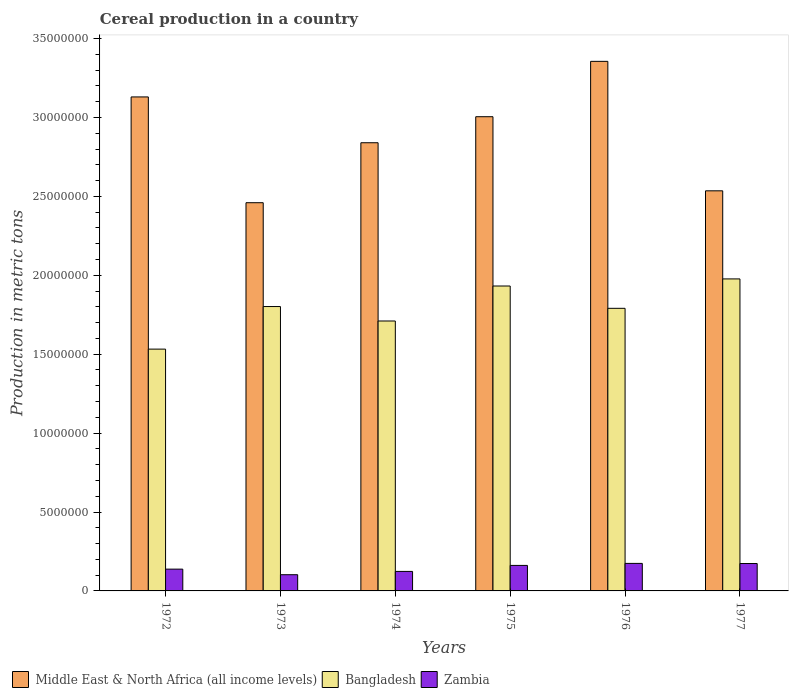How many groups of bars are there?
Give a very brief answer. 6. Are the number of bars on each tick of the X-axis equal?
Ensure brevity in your answer.  Yes. How many bars are there on the 4th tick from the left?
Offer a terse response. 3. How many bars are there on the 6th tick from the right?
Your answer should be compact. 3. What is the label of the 5th group of bars from the left?
Ensure brevity in your answer.  1976. In how many cases, is the number of bars for a given year not equal to the number of legend labels?
Provide a succinct answer. 0. What is the total cereal production in Bangladesh in 1974?
Your response must be concise. 1.71e+07. Across all years, what is the maximum total cereal production in Bangladesh?
Offer a very short reply. 1.98e+07. Across all years, what is the minimum total cereal production in Middle East & North Africa (all income levels)?
Your answer should be compact. 2.46e+07. In which year was the total cereal production in Bangladesh maximum?
Make the answer very short. 1977. What is the total total cereal production in Bangladesh in the graph?
Offer a very short reply. 1.07e+08. What is the difference between the total cereal production in Middle East & North Africa (all income levels) in 1973 and that in 1977?
Offer a terse response. -7.53e+05. What is the difference between the total cereal production in Bangladesh in 1977 and the total cereal production in Middle East & North Africa (all income levels) in 1976?
Offer a terse response. -1.38e+07. What is the average total cereal production in Zambia per year?
Provide a short and direct response. 1.46e+06. In the year 1972, what is the difference between the total cereal production in Middle East & North Africa (all income levels) and total cereal production in Bangladesh?
Provide a short and direct response. 1.60e+07. In how many years, is the total cereal production in Middle East & North Africa (all income levels) greater than 21000000 metric tons?
Provide a short and direct response. 6. What is the ratio of the total cereal production in Zambia in 1974 to that in 1977?
Offer a very short reply. 0.71. Is the total cereal production in Zambia in 1974 less than that in 1977?
Your response must be concise. Yes. What is the difference between the highest and the second highest total cereal production in Zambia?
Provide a succinct answer. 8285. What is the difference between the highest and the lowest total cereal production in Zambia?
Offer a terse response. 7.17e+05. In how many years, is the total cereal production in Zambia greater than the average total cereal production in Zambia taken over all years?
Your answer should be very brief. 3. What does the 3rd bar from the left in 1974 represents?
Provide a short and direct response. Zambia. What does the 2nd bar from the right in 1976 represents?
Ensure brevity in your answer.  Bangladesh. How many bars are there?
Give a very brief answer. 18. Are all the bars in the graph horizontal?
Your answer should be compact. No. How many years are there in the graph?
Provide a succinct answer. 6. Are the values on the major ticks of Y-axis written in scientific E-notation?
Provide a short and direct response. No. What is the title of the graph?
Your answer should be very brief. Cereal production in a country. What is the label or title of the Y-axis?
Your answer should be very brief. Production in metric tons. What is the Production in metric tons in Middle East & North Africa (all income levels) in 1972?
Offer a terse response. 3.13e+07. What is the Production in metric tons of Bangladesh in 1972?
Ensure brevity in your answer.  1.53e+07. What is the Production in metric tons in Zambia in 1972?
Ensure brevity in your answer.  1.38e+06. What is the Production in metric tons of Middle East & North Africa (all income levels) in 1973?
Your answer should be compact. 2.46e+07. What is the Production in metric tons in Bangladesh in 1973?
Make the answer very short. 1.80e+07. What is the Production in metric tons of Zambia in 1973?
Offer a very short reply. 1.03e+06. What is the Production in metric tons of Middle East & North Africa (all income levels) in 1974?
Make the answer very short. 2.84e+07. What is the Production in metric tons in Bangladesh in 1974?
Make the answer very short. 1.71e+07. What is the Production in metric tons in Zambia in 1974?
Your answer should be compact. 1.24e+06. What is the Production in metric tons of Middle East & North Africa (all income levels) in 1975?
Provide a succinct answer. 3.01e+07. What is the Production in metric tons in Bangladesh in 1975?
Make the answer very short. 1.93e+07. What is the Production in metric tons of Zambia in 1975?
Ensure brevity in your answer.  1.62e+06. What is the Production in metric tons of Middle East & North Africa (all income levels) in 1976?
Give a very brief answer. 3.36e+07. What is the Production in metric tons in Bangladesh in 1976?
Offer a terse response. 1.79e+07. What is the Production in metric tons in Zambia in 1976?
Offer a terse response. 1.74e+06. What is the Production in metric tons in Middle East & North Africa (all income levels) in 1977?
Your response must be concise. 2.54e+07. What is the Production in metric tons in Bangladesh in 1977?
Give a very brief answer. 1.98e+07. What is the Production in metric tons in Zambia in 1977?
Give a very brief answer. 1.74e+06. Across all years, what is the maximum Production in metric tons in Middle East & North Africa (all income levels)?
Your answer should be compact. 3.36e+07. Across all years, what is the maximum Production in metric tons of Bangladesh?
Your response must be concise. 1.98e+07. Across all years, what is the maximum Production in metric tons of Zambia?
Give a very brief answer. 1.74e+06. Across all years, what is the minimum Production in metric tons of Middle East & North Africa (all income levels)?
Offer a very short reply. 2.46e+07. Across all years, what is the minimum Production in metric tons of Bangladesh?
Your answer should be very brief. 1.53e+07. Across all years, what is the minimum Production in metric tons of Zambia?
Make the answer very short. 1.03e+06. What is the total Production in metric tons in Middle East & North Africa (all income levels) in the graph?
Your answer should be compact. 1.73e+08. What is the total Production in metric tons of Bangladesh in the graph?
Provide a short and direct response. 1.07e+08. What is the total Production in metric tons of Zambia in the graph?
Your answer should be very brief. 8.74e+06. What is the difference between the Production in metric tons in Middle East & North Africa (all income levels) in 1972 and that in 1973?
Offer a terse response. 6.70e+06. What is the difference between the Production in metric tons in Bangladesh in 1972 and that in 1973?
Ensure brevity in your answer.  -2.70e+06. What is the difference between the Production in metric tons of Zambia in 1972 and that in 1973?
Provide a short and direct response. 3.53e+05. What is the difference between the Production in metric tons in Middle East & North Africa (all income levels) in 1972 and that in 1974?
Ensure brevity in your answer.  2.90e+06. What is the difference between the Production in metric tons in Bangladesh in 1972 and that in 1974?
Offer a terse response. -1.78e+06. What is the difference between the Production in metric tons in Zambia in 1972 and that in 1974?
Offer a terse response. 1.44e+05. What is the difference between the Production in metric tons of Middle East & North Africa (all income levels) in 1972 and that in 1975?
Make the answer very short. 1.25e+06. What is the difference between the Production in metric tons of Bangladesh in 1972 and that in 1975?
Your answer should be compact. -4.00e+06. What is the difference between the Production in metric tons in Zambia in 1972 and that in 1975?
Your response must be concise. -2.36e+05. What is the difference between the Production in metric tons in Middle East & North Africa (all income levels) in 1972 and that in 1976?
Provide a succinct answer. -2.25e+06. What is the difference between the Production in metric tons in Bangladesh in 1972 and that in 1976?
Make the answer very short. -2.58e+06. What is the difference between the Production in metric tons in Zambia in 1972 and that in 1976?
Your answer should be very brief. -3.64e+05. What is the difference between the Production in metric tons in Middle East & North Africa (all income levels) in 1972 and that in 1977?
Give a very brief answer. 5.95e+06. What is the difference between the Production in metric tons of Bangladesh in 1972 and that in 1977?
Your answer should be very brief. -4.45e+06. What is the difference between the Production in metric tons of Zambia in 1972 and that in 1977?
Your answer should be compact. -3.56e+05. What is the difference between the Production in metric tons of Middle East & North Africa (all income levels) in 1973 and that in 1974?
Make the answer very short. -3.80e+06. What is the difference between the Production in metric tons in Bangladesh in 1973 and that in 1974?
Your answer should be very brief. 9.16e+05. What is the difference between the Production in metric tons in Zambia in 1973 and that in 1974?
Offer a very short reply. -2.09e+05. What is the difference between the Production in metric tons in Middle East & North Africa (all income levels) in 1973 and that in 1975?
Your response must be concise. -5.45e+06. What is the difference between the Production in metric tons of Bangladesh in 1973 and that in 1975?
Your answer should be compact. -1.30e+06. What is the difference between the Production in metric tons in Zambia in 1973 and that in 1975?
Offer a very short reply. -5.89e+05. What is the difference between the Production in metric tons in Middle East & North Africa (all income levels) in 1973 and that in 1976?
Your response must be concise. -8.96e+06. What is the difference between the Production in metric tons in Bangladesh in 1973 and that in 1976?
Your response must be concise. 1.13e+05. What is the difference between the Production in metric tons of Zambia in 1973 and that in 1976?
Your response must be concise. -7.17e+05. What is the difference between the Production in metric tons of Middle East & North Africa (all income levels) in 1973 and that in 1977?
Make the answer very short. -7.53e+05. What is the difference between the Production in metric tons of Bangladesh in 1973 and that in 1977?
Provide a succinct answer. -1.75e+06. What is the difference between the Production in metric tons in Zambia in 1973 and that in 1977?
Provide a short and direct response. -7.09e+05. What is the difference between the Production in metric tons of Middle East & North Africa (all income levels) in 1974 and that in 1975?
Your response must be concise. -1.65e+06. What is the difference between the Production in metric tons of Bangladesh in 1974 and that in 1975?
Provide a succinct answer. -2.22e+06. What is the difference between the Production in metric tons in Zambia in 1974 and that in 1975?
Provide a succinct answer. -3.80e+05. What is the difference between the Production in metric tons of Middle East & North Africa (all income levels) in 1974 and that in 1976?
Offer a terse response. -5.16e+06. What is the difference between the Production in metric tons in Bangladesh in 1974 and that in 1976?
Make the answer very short. -8.03e+05. What is the difference between the Production in metric tons of Zambia in 1974 and that in 1976?
Offer a terse response. -5.08e+05. What is the difference between the Production in metric tons in Middle East & North Africa (all income levels) in 1974 and that in 1977?
Ensure brevity in your answer.  3.05e+06. What is the difference between the Production in metric tons of Bangladesh in 1974 and that in 1977?
Keep it short and to the point. -2.67e+06. What is the difference between the Production in metric tons in Zambia in 1974 and that in 1977?
Offer a terse response. -5.00e+05. What is the difference between the Production in metric tons in Middle East & North Africa (all income levels) in 1975 and that in 1976?
Ensure brevity in your answer.  -3.51e+06. What is the difference between the Production in metric tons in Bangladesh in 1975 and that in 1976?
Provide a succinct answer. 1.41e+06. What is the difference between the Production in metric tons in Zambia in 1975 and that in 1976?
Offer a very short reply. -1.28e+05. What is the difference between the Production in metric tons of Middle East & North Africa (all income levels) in 1975 and that in 1977?
Your answer should be very brief. 4.70e+06. What is the difference between the Production in metric tons of Bangladesh in 1975 and that in 1977?
Give a very brief answer. -4.50e+05. What is the difference between the Production in metric tons of Zambia in 1975 and that in 1977?
Ensure brevity in your answer.  -1.20e+05. What is the difference between the Production in metric tons in Middle East & North Africa (all income levels) in 1976 and that in 1977?
Provide a short and direct response. 8.20e+06. What is the difference between the Production in metric tons of Bangladesh in 1976 and that in 1977?
Your answer should be compact. -1.86e+06. What is the difference between the Production in metric tons of Zambia in 1976 and that in 1977?
Provide a succinct answer. 8285. What is the difference between the Production in metric tons in Middle East & North Africa (all income levels) in 1972 and the Production in metric tons in Bangladesh in 1973?
Offer a terse response. 1.33e+07. What is the difference between the Production in metric tons in Middle East & North Africa (all income levels) in 1972 and the Production in metric tons in Zambia in 1973?
Provide a succinct answer. 3.03e+07. What is the difference between the Production in metric tons of Bangladesh in 1972 and the Production in metric tons of Zambia in 1973?
Offer a very short reply. 1.43e+07. What is the difference between the Production in metric tons in Middle East & North Africa (all income levels) in 1972 and the Production in metric tons in Bangladesh in 1974?
Provide a short and direct response. 1.42e+07. What is the difference between the Production in metric tons in Middle East & North Africa (all income levels) in 1972 and the Production in metric tons in Zambia in 1974?
Offer a very short reply. 3.01e+07. What is the difference between the Production in metric tons in Bangladesh in 1972 and the Production in metric tons in Zambia in 1974?
Your answer should be compact. 1.41e+07. What is the difference between the Production in metric tons in Middle East & North Africa (all income levels) in 1972 and the Production in metric tons in Bangladesh in 1975?
Give a very brief answer. 1.20e+07. What is the difference between the Production in metric tons in Middle East & North Africa (all income levels) in 1972 and the Production in metric tons in Zambia in 1975?
Your answer should be compact. 2.97e+07. What is the difference between the Production in metric tons of Bangladesh in 1972 and the Production in metric tons of Zambia in 1975?
Make the answer very short. 1.37e+07. What is the difference between the Production in metric tons of Middle East & North Africa (all income levels) in 1972 and the Production in metric tons of Bangladesh in 1976?
Offer a terse response. 1.34e+07. What is the difference between the Production in metric tons in Middle East & North Africa (all income levels) in 1972 and the Production in metric tons in Zambia in 1976?
Offer a terse response. 2.96e+07. What is the difference between the Production in metric tons in Bangladesh in 1972 and the Production in metric tons in Zambia in 1976?
Your answer should be compact. 1.36e+07. What is the difference between the Production in metric tons of Middle East & North Africa (all income levels) in 1972 and the Production in metric tons of Bangladesh in 1977?
Offer a very short reply. 1.15e+07. What is the difference between the Production in metric tons in Middle East & North Africa (all income levels) in 1972 and the Production in metric tons in Zambia in 1977?
Your answer should be compact. 2.96e+07. What is the difference between the Production in metric tons of Bangladesh in 1972 and the Production in metric tons of Zambia in 1977?
Provide a short and direct response. 1.36e+07. What is the difference between the Production in metric tons in Middle East & North Africa (all income levels) in 1973 and the Production in metric tons in Bangladesh in 1974?
Give a very brief answer. 7.50e+06. What is the difference between the Production in metric tons of Middle East & North Africa (all income levels) in 1973 and the Production in metric tons of Zambia in 1974?
Your answer should be compact. 2.34e+07. What is the difference between the Production in metric tons of Bangladesh in 1973 and the Production in metric tons of Zambia in 1974?
Provide a succinct answer. 1.68e+07. What is the difference between the Production in metric tons of Middle East & North Africa (all income levels) in 1973 and the Production in metric tons of Bangladesh in 1975?
Make the answer very short. 5.28e+06. What is the difference between the Production in metric tons of Middle East & North Africa (all income levels) in 1973 and the Production in metric tons of Zambia in 1975?
Your answer should be very brief. 2.30e+07. What is the difference between the Production in metric tons in Bangladesh in 1973 and the Production in metric tons in Zambia in 1975?
Ensure brevity in your answer.  1.64e+07. What is the difference between the Production in metric tons of Middle East & North Africa (all income levels) in 1973 and the Production in metric tons of Bangladesh in 1976?
Your answer should be very brief. 6.69e+06. What is the difference between the Production in metric tons in Middle East & North Africa (all income levels) in 1973 and the Production in metric tons in Zambia in 1976?
Provide a short and direct response. 2.29e+07. What is the difference between the Production in metric tons in Bangladesh in 1973 and the Production in metric tons in Zambia in 1976?
Provide a succinct answer. 1.63e+07. What is the difference between the Production in metric tons of Middle East & North Africa (all income levels) in 1973 and the Production in metric tons of Bangladesh in 1977?
Offer a very short reply. 4.83e+06. What is the difference between the Production in metric tons in Middle East & North Africa (all income levels) in 1973 and the Production in metric tons in Zambia in 1977?
Keep it short and to the point. 2.29e+07. What is the difference between the Production in metric tons in Bangladesh in 1973 and the Production in metric tons in Zambia in 1977?
Ensure brevity in your answer.  1.63e+07. What is the difference between the Production in metric tons in Middle East & North Africa (all income levels) in 1974 and the Production in metric tons in Bangladesh in 1975?
Provide a succinct answer. 9.08e+06. What is the difference between the Production in metric tons in Middle East & North Africa (all income levels) in 1974 and the Production in metric tons in Zambia in 1975?
Your answer should be compact. 2.68e+07. What is the difference between the Production in metric tons of Bangladesh in 1974 and the Production in metric tons of Zambia in 1975?
Provide a succinct answer. 1.55e+07. What is the difference between the Production in metric tons in Middle East & North Africa (all income levels) in 1974 and the Production in metric tons in Bangladesh in 1976?
Ensure brevity in your answer.  1.05e+07. What is the difference between the Production in metric tons of Middle East & North Africa (all income levels) in 1974 and the Production in metric tons of Zambia in 1976?
Keep it short and to the point. 2.67e+07. What is the difference between the Production in metric tons of Bangladesh in 1974 and the Production in metric tons of Zambia in 1976?
Make the answer very short. 1.54e+07. What is the difference between the Production in metric tons in Middle East & North Africa (all income levels) in 1974 and the Production in metric tons in Bangladesh in 1977?
Offer a terse response. 8.63e+06. What is the difference between the Production in metric tons of Middle East & North Africa (all income levels) in 1974 and the Production in metric tons of Zambia in 1977?
Provide a succinct answer. 2.67e+07. What is the difference between the Production in metric tons in Bangladesh in 1974 and the Production in metric tons in Zambia in 1977?
Ensure brevity in your answer.  1.54e+07. What is the difference between the Production in metric tons of Middle East & North Africa (all income levels) in 1975 and the Production in metric tons of Bangladesh in 1976?
Offer a very short reply. 1.21e+07. What is the difference between the Production in metric tons of Middle East & North Africa (all income levels) in 1975 and the Production in metric tons of Zambia in 1976?
Offer a very short reply. 2.83e+07. What is the difference between the Production in metric tons in Bangladesh in 1975 and the Production in metric tons in Zambia in 1976?
Ensure brevity in your answer.  1.76e+07. What is the difference between the Production in metric tons in Middle East & North Africa (all income levels) in 1975 and the Production in metric tons in Bangladesh in 1977?
Your response must be concise. 1.03e+07. What is the difference between the Production in metric tons in Middle East & North Africa (all income levels) in 1975 and the Production in metric tons in Zambia in 1977?
Your answer should be compact. 2.83e+07. What is the difference between the Production in metric tons of Bangladesh in 1975 and the Production in metric tons of Zambia in 1977?
Your answer should be compact. 1.76e+07. What is the difference between the Production in metric tons of Middle East & North Africa (all income levels) in 1976 and the Production in metric tons of Bangladesh in 1977?
Make the answer very short. 1.38e+07. What is the difference between the Production in metric tons of Middle East & North Africa (all income levels) in 1976 and the Production in metric tons of Zambia in 1977?
Offer a terse response. 3.18e+07. What is the difference between the Production in metric tons in Bangladesh in 1976 and the Production in metric tons in Zambia in 1977?
Provide a succinct answer. 1.62e+07. What is the average Production in metric tons in Middle East & North Africa (all income levels) per year?
Offer a terse response. 2.89e+07. What is the average Production in metric tons in Bangladesh per year?
Offer a terse response. 1.79e+07. What is the average Production in metric tons in Zambia per year?
Your response must be concise. 1.46e+06. In the year 1972, what is the difference between the Production in metric tons of Middle East & North Africa (all income levels) and Production in metric tons of Bangladesh?
Give a very brief answer. 1.60e+07. In the year 1972, what is the difference between the Production in metric tons in Middle East & North Africa (all income levels) and Production in metric tons in Zambia?
Offer a terse response. 2.99e+07. In the year 1972, what is the difference between the Production in metric tons in Bangladesh and Production in metric tons in Zambia?
Your answer should be compact. 1.39e+07. In the year 1973, what is the difference between the Production in metric tons of Middle East & North Africa (all income levels) and Production in metric tons of Bangladesh?
Provide a succinct answer. 6.58e+06. In the year 1973, what is the difference between the Production in metric tons in Middle East & North Africa (all income levels) and Production in metric tons in Zambia?
Keep it short and to the point. 2.36e+07. In the year 1973, what is the difference between the Production in metric tons in Bangladesh and Production in metric tons in Zambia?
Provide a succinct answer. 1.70e+07. In the year 1974, what is the difference between the Production in metric tons in Middle East & North Africa (all income levels) and Production in metric tons in Bangladesh?
Your answer should be compact. 1.13e+07. In the year 1974, what is the difference between the Production in metric tons of Middle East & North Africa (all income levels) and Production in metric tons of Zambia?
Offer a very short reply. 2.72e+07. In the year 1974, what is the difference between the Production in metric tons of Bangladesh and Production in metric tons of Zambia?
Your answer should be compact. 1.59e+07. In the year 1975, what is the difference between the Production in metric tons in Middle East & North Africa (all income levels) and Production in metric tons in Bangladesh?
Give a very brief answer. 1.07e+07. In the year 1975, what is the difference between the Production in metric tons in Middle East & North Africa (all income levels) and Production in metric tons in Zambia?
Provide a short and direct response. 2.84e+07. In the year 1975, what is the difference between the Production in metric tons in Bangladesh and Production in metric tons in Zambia?
Make the answer very short. 1.77e+07. In the year 1976, what is the difference between the Production in metric tons of Middle East & North Africa (all income levels) and Production in metric tons of Bangladesh?
Offer a very short reply. 1.57e+07. In the year 1976, what is the difference between the Production in metric tons of Middle East & North Africa (all income levels) and Production in metric tons of Zambia?
Keep it short and to the point. 3.18e+07. In the year 1976, what is the difference between the Production in metric tons of Bangladesh and Production in metric tons of Zambia?
Your answer should be very brief. 1.62e+07. In the year 1977, what is the difference between the Production in metric tons of Middle East & North Africa (all income levels) and Production in metric tons of Bangladesh?
Offer a very short reply. 5.58e+06. In the year 1977, what is the difference between the Production in metric tons of Middle East & North Africa (all income levels) and Production in metric tons of Zambia?
Your answer should be very brief. 2.36e+07. In the year 1977, what is the difference between the Production in metric tons in Bangladesh and Production in metric tons in Zambia?
Your answer should be compact. 1.80e+07. What is the ratio of the Production in metric tons of Middle East & North Africa (all income levels) in 1972 to that in 1973?
Ensure brevity in your answer.  1.27. What is the ratio of the Production in metric tons of Bangladesh in 1972 to that in 1973?
Keep it short and to the point. 0.85. What is the ratio of the Production in metric tons in Zambia in 1972 to that in 1973?
Provide a succinct answer. 1.34. What is the ratio of the Production in metric tons in Middle East & North Africa (all income levels) in 1972 to that in 1974?
Give a very brief answer. 1.1. What is the ratio of the Production in metric tons in Bangladesh in 1972 to that in 1974?
Your response must be concise. 0.9. What is the ratio of the Production in metric tons of Zambia in 1972 to that in 1974?
Your response must be concise. 1.12. What is the ratio of the Production in metric tons of Middle East & North Africa (all income levels) in 1972 to that in 1975?
Offer a very short reply. 1.04. What is the ratio of the Production in metric tons of Bangladesh in 1972 to that in 1975?
Offer a very short reply. 0.79. What is the ratio of the Production in metric tons of Zambia in 1972 to that in 1975?
Ensure brevity in your answer.  0.85. What is the ratio of the Production in metric tons in Middle East & North Africa (all income levels) in 1972 to that in 1976?
Make the answer very short. 0.93. What is the ratio of the Production in metric tons of Bangladesh in 1972 to that in 1976?
Offer a terse response. 0.86. What is the ratio of the Production in metric tons of Zambia in 1972 to that in 1976?
Provide a succinct answer. 0.79. What is the ratio of the Production in metric tons of Middle East & North Africa (all income levels) in 1972 to that in 1977?
Provide a short and direct response. 1.23. What is the ratio of the Production in metric tons in Bangladesh in 1972 to that in 1977?
Give a very brief answer. 0.78. What is the ratio of the Production in metric tons of Zambia in 1972 to that in 1977?
Make the answer very short. 0.8. What is the ratio of the Production in metric tons in Middle East & North Africa (all income levels) in 1973 to that in 1974?
Offer a very short reply. 0.87. What is the ratio of the Production in metric tons of Bangladesh in 1973 to that in 1974?
Your response must be concise. 1.05. What is the ratio of the Production in metric tons of Zambia in 1973 to that in 1974?
Offer a terse response. 0.83. What is the ratio of the Production in metric tons of Middle East & North Africa (all income levels) in 1973 to that in 1975?
Your answer should be compact. 0.82. What is the ratio of the Production in metric tons of Bangladesh in 1973 to that in 1975?
Provide a short and direct response. 0.93. What is the ratio of the Production in metric tons in Zambia in 1973 to that in 1975?
Make the answer very short. 0.64. What is the ratio of the Production in metric tons of Middle East & North Africa (all income levels) in 1973 to that in 1976?
Offer a very short reply. 0.73. What is the ratio of the Production in metric tons in Bangladesh in 1973 to that in 1976?
Keep it short and to the point. 1.01. What is the ratio of the Production in metric tons in Zambia in 1973 to that in 1976?
Provide a succinct answer. 0.59. What is the ratio of the Production in metric tons in Middle East & North Africa (all income levels) in 1973 to that in 1977?
Offer a terse response. 0.97. What is the ratio of the Production in metric tons in Bangladesh in 1973 to that in 1977?
Provide a succinct answer. 0.91. What is the ratio of the Production in metric tons of Zambia in 1973 to that in 1977?
Keep it short and to the point. 0.59. What is the ratio of the Production in metric tons of Middle East & North Africa (all income levels) in 1974 to that in 1975?
Ensure brevity in your answer.  0.95. What is the ratio of the Production in metric tons in Bangladesh in 1974 to that in 1975?
Offer a very short reply. 0.89. What is the ratio of the Production in metric tons in Zambia in 1974 to that in 1975?
Your answer should be compact. 0.76. What is the ratio of the Production in metric tons in Middle East & North Africa (all income levels) in 1974 to that in 1976?
Provide a succinct answer. 0.85. What is the ratio of the Production in metric tons in Bangladesh in 1974 to that in 1976?
Provide a succinct answer. 0.96. What is the ratio of the Production in metric tons of Zambia in 1974 to that in 1976?
Your answer should be compact. 0.71. What is the ratio of the Production in metric tons of Middle East & North Africa (all income levels) in 1974 to that in 1977?
Provide a short and direct response. 1.12. What is the ratio of the Production in metric tons of Bangladesh in 1974 to that in 1977?
Provide a succinct answer. 0.87. What is the ratio of the Production in metric tons in Zambia in 1974 to that in 1977?
Your answer should be compact. 0.71. What is the ratio of the Production in metric tons of Middle East & North Africa (all income levels) in 1975 to that in 1976?
Provide a succinct answer. 0.9. What is the ratio of the Production in metric tons of Bangladesh in 1975 to that in 1976?
Give a very brief answer. 1.08. What is the ratio of the Production in metric tons in Zambia in 1975 to that in 1976?
Your answer should be very brief. 0.93. What is the ratio of the Production in metric tons in Middle East & North Africa (all income levels) in 1975 to that in 1977?
Make the answer very short. 1.19. What is the ratio of the Production in metric tons of Bangladesh in 1975 to that in 1977?
Make the answer very short. 0.98. What is the ratio of the Production in metric tons of Zambia in 1975 to that in 1977?
Give a very brief answer. 0.93. What is the ratio of the Production in metric tons in Middle East & North Africa (all income levels) in 1976 to that in 1977?
Offer a terse response. 1.32. What is the ratio of the Production in metric tons in Bangladesh in 1976 to that in 1977?
Your answer should be compact. 0.91. What is the difference between the highest and the second highest Production in metric tons in Middle East & North Africa (all income levels)?
Give a very brief answer. 2.25e+06. What is the difference between the highest and the second highest Production in metric tons in Bangladesh?
Provide a succinct answer. 4.50e+05. What is the difference between the highest and the second highest Production in metric tons in Zambia?
Make the answer very short. 8285. What is the difference between the highest and the lowest Production in metric tons in Middle East & North Africa (all income levels)?
Offer a very short reply. 8.96e+06. What is the difference between the highest and the lowest Production in metric tons in Bangladesh?
Ensure brevity in your answer.  4.45e+06. What is the difference between the highest and the lowest Production in metric tons of Zambia?
Your response must be concise. 7.17e+05. 